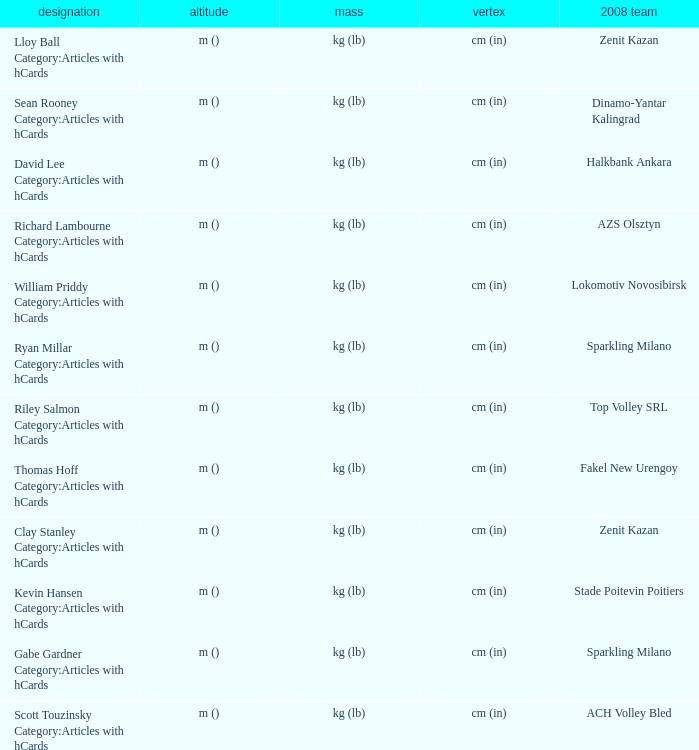What is the spike for the 2008 club of Lokomotiv Novosibirsk? Cm (in). 